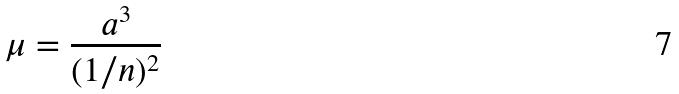Convert formula to latex. <formula><loc_0><loc_0><loc_500><loc_500>\mu = \frac { a ^ { 3 } } { ( 1 / n ) ^ { 2 } }</formula> 